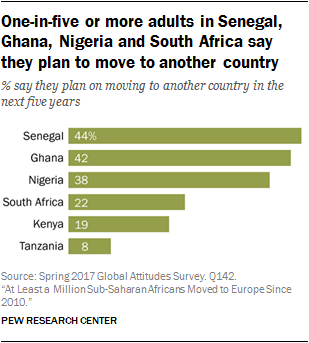Draw attention to some important aspects in this diagram. The average of the last four countries listed from the bottom to the top is 21.75. Tanzania is at the bottom of the table. 